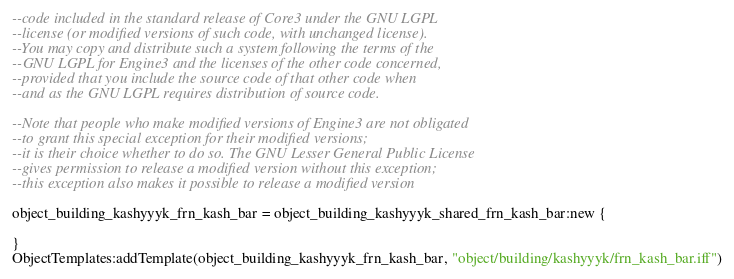<code> <loc_0><loc_0><loc_500><loc_500><_Lua_>--code included in the standard release of Core3 under the GNU LGPL 
--license (or modified versions of such code, with unchanged license). 
--You may copy and distribute such a system following the terms of the 
--GNU LGPL for Engine3 and the licenses of the other code concerned, 
--provided that you include the source code of that other code when 
--and as the GNU LGPL requires distribution of source code.

--Note that people who make modified versions of Engine3 are not obligated 
--to grant this special exception for their modified versions; 
--it is their choice whether to do so. The GNU Lesser General Public License 
--gives permission to release a modified version without this exception; 
--this exception also makes it possible to release a modified version 

object_building_kashyyyk_frn_kash_bar = object_building_kashyyyk_shared_frn_kash_bar:new {

}
ObjectTemplates:addTemplate(object_building_kashyyyk_frn_kash_bar, "object/building/kashyyyk/frn_kash_bar.iff")
</code> 